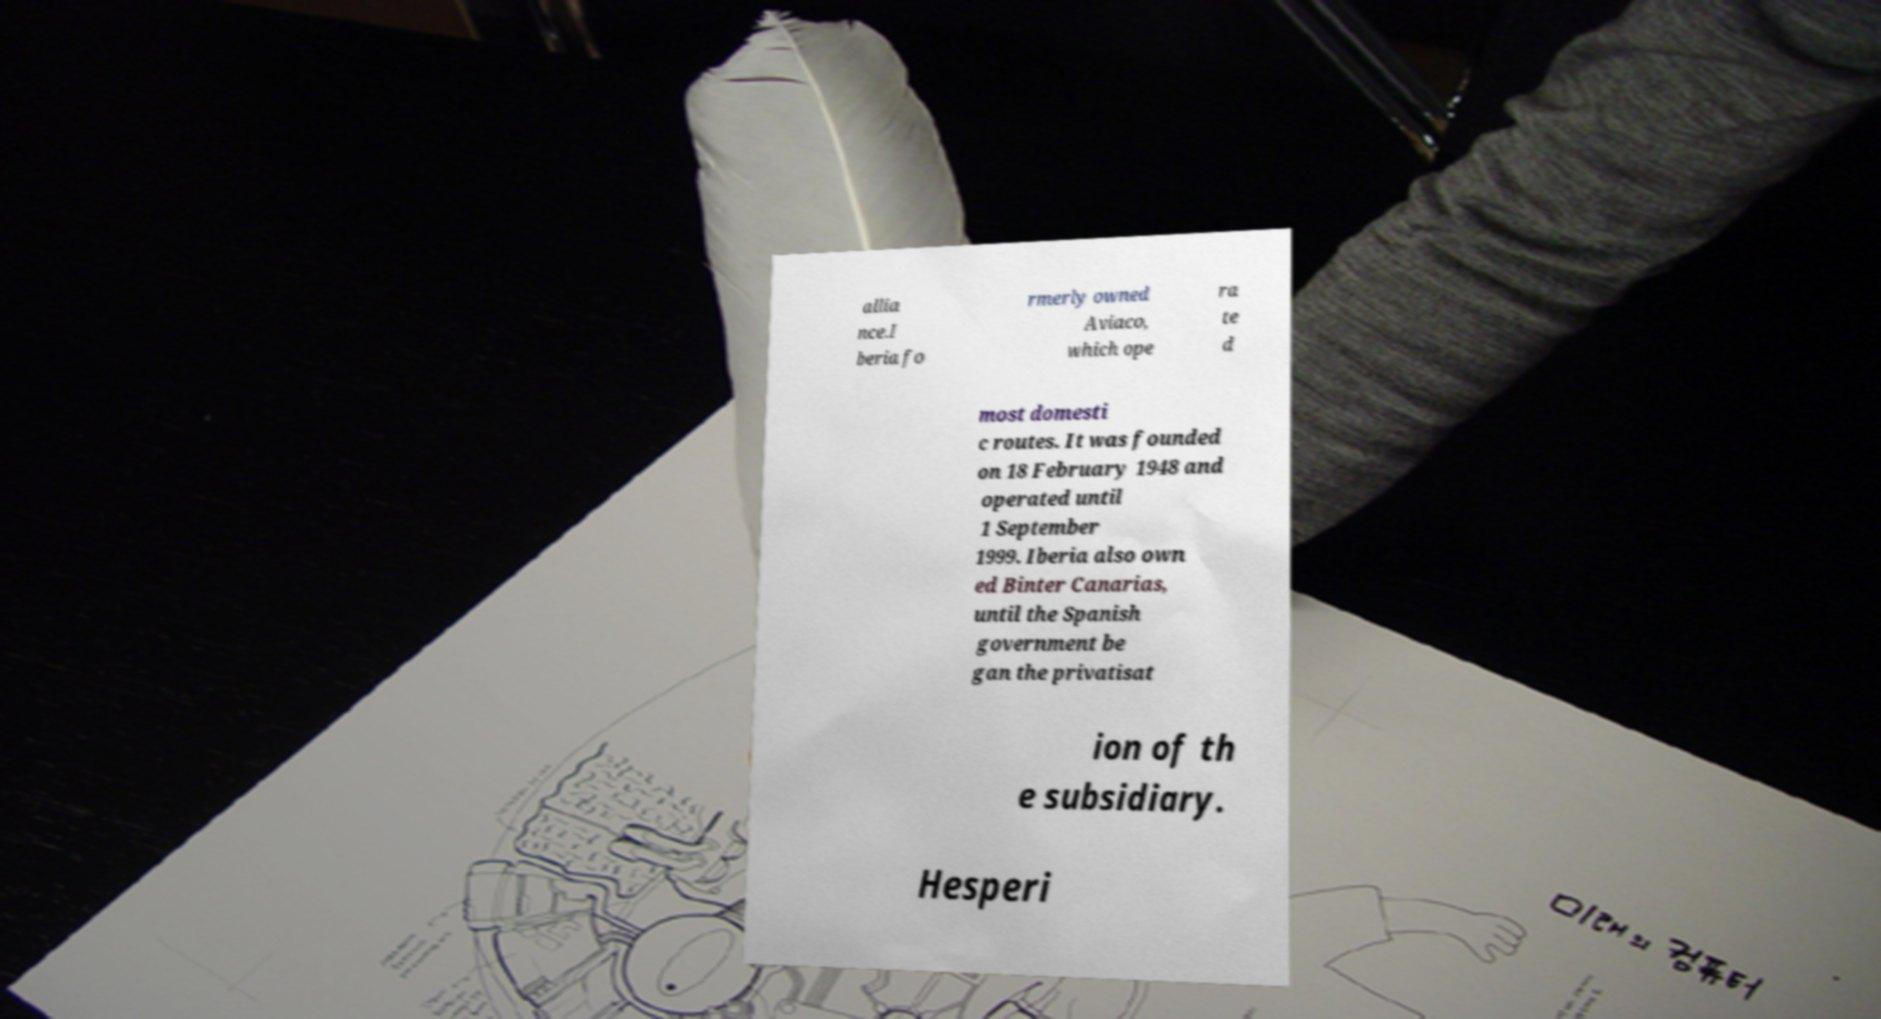Please read and relay the text visible in this image. What does it say? allia nce.I beria fo rmerly owned Aviaco, which ope ra te d most domesti c routes. It was founded on 18 February 1948 and operated until 1 September 1999. Iberia also own ed Binter Canarias, until the Spanish government be gan the privatisat ion of th e subsidiary. Hesperi 